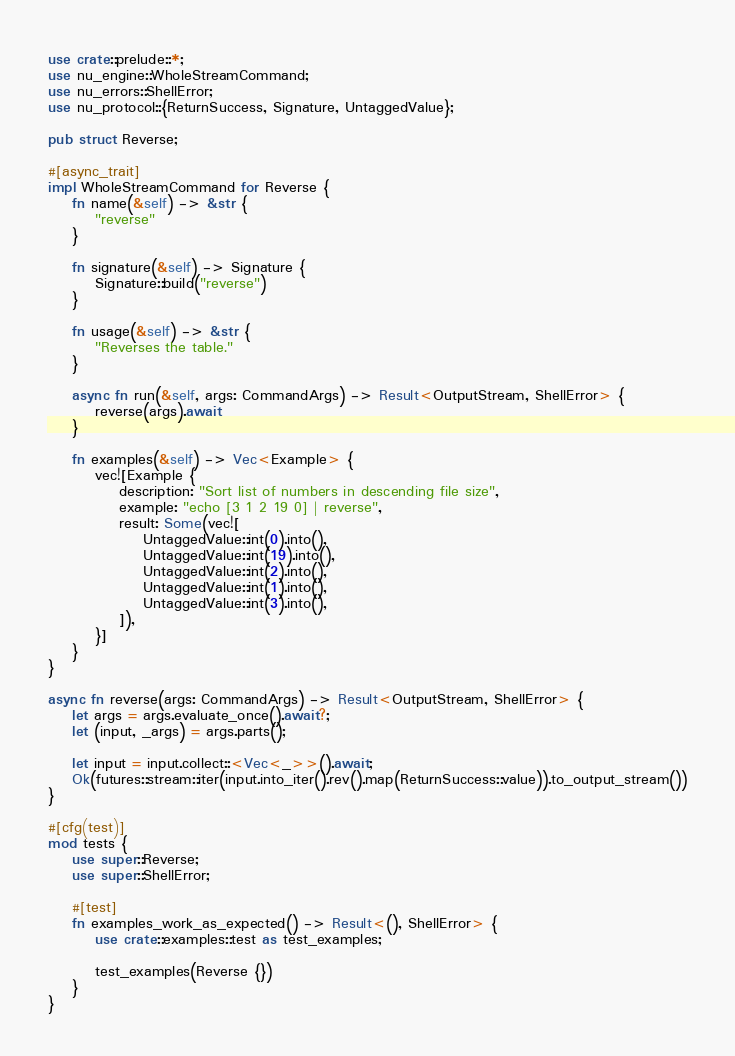<code> <loc_0><loc_0><loc_500><loc_500><_Rust_>use crate::prelude::*;
use nu_engine::WholeStreamCommand;
use nu_errors::ShellError;
use nu_protocol::{ReturnSuccess, Signature, UntaggedValue};

pub struct Reverse;

#[async_trait]
impl WholeStreamCommand for Reverse {
    fn name(&self) -> &str {
        "reverse"
    }

    fn signature(&self) -> Signature {
        Signature::build("reverse")
    }

    fn usage(&self) -> &str {
        "Reverses the table."
    }

    async fn run(&self, args: CommandArgs) -> Result<OutputStream, ShellError> {
        reverse(args).await
    }

    fn examples(&self) -> Vec<Example> {
        vec![Example {
            description: "Sort list of numbers in descending file size",
            example: "echo [3 1 2 19 0] | reverse",
            result: Some(vec![
                UntaggedValue::int(0).into(),
                UntaggedValue::int(19).into(),
                UntaggedValue::int(2).into(),
                UntaggedValue::int(1).into(),
                UntaggedValue::int(3).into(),
            ]),
        }]
    }
}

async fn reverse(args: CommandArgs) -> Result<OutputStream, ShellError> {
    let args = args.evaluate_once().await?;
    let (input, _args) = args.parts();

    let input = input.collect::<Vec<_>>().await;
    Ok(futures::stream::iter(input.into_iter().rev().map(ReturnSuccess::value)).to_output_stream())
}

#[cfg(test)]
mod tests {
    use super::Reverse;
    use super::ShellError;

    #[test]
    fn examples_work_as_expected() -> Result<(), ShellError> {
        use crate::examples::test as test_examples;

        test_examples(Reverse {})
    }
}
</code> 